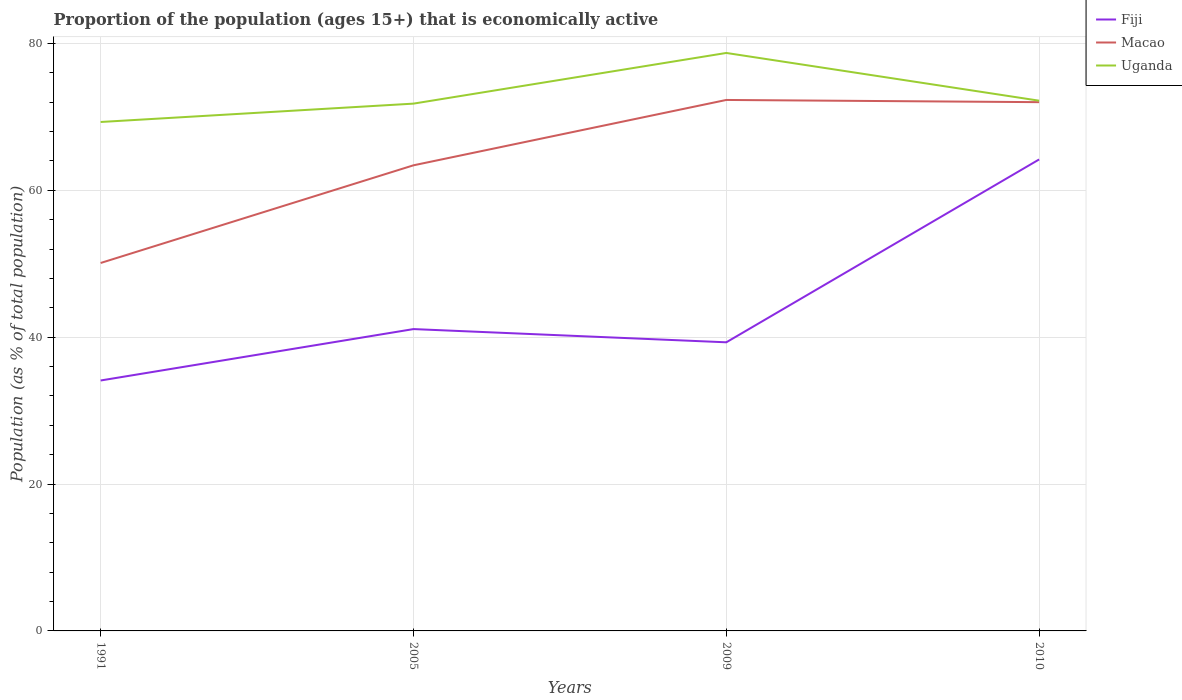How many different coloured lines are there?
Make the answer very short. 3. Is the number of lines equal to the number of legend labels?
Your response must be concise. Yes. Across all years, what is the maximum proportion of the population that is economically active in Uganda?
Ensure brevity in your answer.  69.3. What is the total proportion of the population that is economically active in Macao in the graph?
Offer a terse response. -13.3. What is the difference between the highest and the second highest proportion of the population that is economically active in Macao?
Make the answer very short. 22.2. Is the proportion of the population that is economically active in Uganda strictly greater than the proportion of the population that is economically active in Fiji over the years?
Offer a very short reply. No. How many lines are there?
Keep it short and to the point. 3. How many years are there in the graph?
Ensure brevity in your answer.  4. Does the graph contain any zero values?
Provide a succinct answer. No. Does the graph contain grids?
Offer a very short reply. Yes. Where does the legend appear in the graph?
Offer a very short reply. Top right. How are the legend labels stacked?
Offer a very short reply. Vertical. What is the title of the graph?
Your response must be concise. Proportion of the population (ages 15+) that is economically active. Does "San Marino" appear as one of the legend labels in the graph?
Your response must be concise. No. What is the label or title of the Y-axis?
Give a very brief answer. Population (as % of total population). What is the Population (as % of total population) in Fiji in 1991?
Provide a short and direct response. 34.1. What is the Population (as % of total population) of Macao in 1991?
Ensure brevity in your answer.  50.1. What is the Population (as % of total population) of Uganda in 1991?
Offer a terse response. 69.3. What is the Population (as % of total population) of Fiji in 2005?
Make the answer very short. 41.1. What is the Population (as % of total population) in Macao in 2005?
Offer a very short reply. 63.4. What is the Population (as % of total population) of Uganda in 2005?
Provide a succinct answer. 71.8. What is the Population (as % of total population) in Fiji in 2009?
Provide a short and direct response. 39.3. What is the Population (as % of total population) of Macao in 2009?
Provide a short and direct response. 72.3. What is the Population (as % of total population) of Uganda in 2009?
Your answer should be compact. 78.7. What is the Population (as % of total population) in Fiji in 2010?
Your answer should be very brief. 64.2. What is the Population (as % of total population) in Uganda in 2010?
Provide a succinct answer. 72.2. Across all years, what is the maximum Population (as % of total population) of Fiji?
Provide a short and direct response. 64.2. Across all years, what is the maximum Population (as % of total population) in Macao?
Provide a short and direct response. 72.3. Across all years, what is the maximum Population (as % of total population) in Uganda?
Make the answer very short. 78.7. Across all years, what is the minimum Population (as % of total population) in Fiji?
Give a very brief answer. 34.1. Across all years, what is the minimum Population (as % of total population) of Macao?
Your answer should be very brief. 50.1. Across all years, what is the minimum Population (as % of total population) of Uganda?
Give a very brief answer. 69.3. What is the total Population (as % of total population) in Fiji in the graph?
Ensure brevity in your answer.  178.7. What is the total Population (as % of total population) of Macao in the graph?
Keep it short and to the point. 257.8. What is the total Population (as % of total population) of Uganda in the graph?
Provide a succinct answer. 292. What is the difference between the Population (as % of total population) of Fiji in 1991 and that in 2005?
Your response must be concise. -7. What is the difference between the Population (as % of total population) in Macao in 1991 and that in 2005?
Provide a succinct answer. -13.3. What is the difference between the Population (as % of total population) of Uganda in 1991 and that in 2005?
Keep it short and to the point. -2.5. What is the difference between the Population (as % of total population) in Macao in 1991 and that in 2009?
Make the answer very short. -22.2. What is the difference between the Population (as % of total population) in Uganda in 1991 and that in 2009?
Offer a terse response. -9.4. What is the difference between the Population (as % of total population) in Fiji in 1991 and that in 2010?
Your response must be concise. -30.1. What is the difference between the Population (as % of total population) of Macao in 1991 and that in 2010?
Offer a terse response. -21.9. What is the difference between the Population (as % of total population) of Uganda in 2005 and that in 2009?
Ensure brevity in your answer.  -6.9. What is the difference between the Population (as % of total population) in Fiji in 2005 and that in 2010?
Make the answer very short. -23.1. What is the difference between the Population (as % of total population) in Macao in 2005 and that in 2010?
Offer a very short reply. -8.6. What is the difference between the Population (as % of total population) of Uganda in 2005 and that in 2010?
Give a very brief answer. -0.4. What is the difference between the Population (as % of total population) of Fiji in 2009 and that in 2010?
Make the answer very short. -24.9. What is the difference between the Population (as % of total population) of Fiji in 1991 and the Population (as % of total population) of Macao in 2005?
Your answer should be compact. -29.3. What is the difference between the Population (as % of total population) of Fiji in 1991 and the Population (as % of total population) of Uganda in 2005?
Make the answer very short. -37.7. What is the difference between the Population (as % of total population) in Macao in 1991 and the Population (as % of total population) in Uganda in 2005?
Your response must be concise. -21.7. What is the difference between the Population (as % of total population) of Fiji in 1991 and the Population (as % of total population) of Macao in 2009?
Offer a very short reply. -38.2. What is the difference between the Population (as % of total population) in Fiji in 1991 and the Population (as % of total population) in Uganda in 2009?
Your answer should be very brief. -44.6. What is the difference between the Population (as % of total population) in Macao in 1991 and the Population (as % of total population) in Uganda in 2009?
Make the answer very short. -28.6. What is the difference between the Population (as % of total population) of Fiji in 1991 and the Population (as % of total population) of Macao in 2010?
Keep it short and to the point. -37.9. What is the difference between the Population (as % of total population) in Fiji in 1991 and the Population (as % of total population) in Uganda in 2010?
Provide a short and direct response. -38.1. What is the difference between the Population (as % of total population) in Macao in 1991 and the Population (as % of total population) in Uganda in 2010?
Your answer should be compact. -22.1. What is the difference between the Population (as % of total population) in Fiji in 2005 and the Population (as % of total population) in Macao in 2009?
Your answer should be compact. -31.2. What is the difference between the Population (as % of total population) in Fiji in 2005 and the Population (as % of total population) in Uganda in 2009?
Keep it short and to the point. -37.6. What is the difference between the Population (as % of total population) in Macao in 2005 and the Population (as % of total population) in Uganda in 2009?
Offer a very short reply. -15.3. What is the difference between the Population (as % of total population) in Fiji in 2005 and the Population (as % of total population) in Macao in 2010?
Provide a succinct answer. -30.9. What is the difference between the Population (as % of total population) in Fiji in 2005 and the Population (as % of total population) in Uganda in 2010?
Provide a short and direct response. -31.1. What is the difference between the Population (as % of total population) of Macao in 2005 and the Population (as % of total population) of Uganda in 2010?
Your response must be concise. -8.8. What is the difference between the Population (as % of total population) in Fiji in 2009 and the Population (as % of total population) in Macao in 2010?
Your answer should be very brief. -32.7. What is the difference between the Population (as % of total population) in Fiji in 2009 and the Population (as % of total population) in Uganda in 2010?
Your response must be concise. -32.9. What is the average Population (as % of total population) of Fiji per year?
Ensure brevity in your answer.  44.67. What is the average Population (as % of total population) of Macao per year?
Offer a very short reply. 64.45. In the year 1991, what is the difference between the Population (as % of total population) in Fiji and Population (as % of total population) in Macao?
Offer a terse response. -16. In the year 1991, what is the difference between the Population (as % of total population) in Fiji and Population (as % of total population) in Uganda?
Ensure brevity in your answer.  -35.2. In the year 1991, what is the difference between the Population (as % of total population) of Macao and Population (as % of total population) of Uganda?
Your answer should be very brief. -19.2. In the year 2005, what is the difference between the Population (as % of total population) in Fiji and Population (as % of total population) in Macao?
Provide a succinct answer. -22.3. In the year 2005, what is the difference between the Population (as % of total population) in Fiji and Population (as % of total population) in Uganda?
Your response must be concise. -30.7. In the year 2009, what is the difference between the Population (as % of total population) in Fiji and Population (as % of total population) in Macao?
Make the answer very short. -33. In the year 2009, what is the difference between the Population (as % of total population) of Fiji and Population (as % of total population) of Uganda?
Your answer should be compact. -39.4. In the year 2009, what is the difference between the Population (as % of total population) of Macao and Population (as % of total population) of Uganda?
Offer a very short reply. -6.4. In the year 2010, what is the difference between the Population (as % of total population) of Fiji and Population (as % of total population) of Macao?
Provide a short and direct response. -7.8. In the year 2010, what is the difference between the Population (as % of total population) of Fiji and Population (as % of total population) of Uganda?
Provide a short and direct response. -8. In the year 2010, what is the difference between the Population (as % of total population) of Macao and Population (as % of total population) of Uganda?
Ensure brevity in your answer.  -0.2. What is the ratio of the Population (as % of total population) of Fiji in 1991 to that in 2005?
Give a very brief answer. 0.83. What is the ratio of the Population (as % of total population) in Macao in 1991 to that in 2005?
Make the answer very short. 0.79. What is the ratio of the Population (as % of total population) in Uganda in 1991 to that in 2005?
Provide a short and direct response. 0.97. What is the ratio of the Population (as % of total population) of Fiji in 1991 to that in 2009?
Your answer should be compact. 0.87. What is the ratio of the Population (as % of total population) in Macao in 1991 to that in 2009?
Offer a terse response. 0.69. What is the ratio of the Population (as % of total population) in Uganda in 1991 to that in 2009?
Your answer should be very brief. 0.88. What is the ratio of the Population (as % of total population) of Fiji in 1991 to that in 2010?
Your answer should be compact. 0.53. What is the ratio of the Population (as % of total population) in Macao in 1991 to that in 2010?
Offer a terse response. 0.7. What is the ratio of the Population (as % of total population) of Uganda in 1991 to that in 2010?
Your response must be concise. 0.96. What is the ratio of the Population (as % of total population) of Fiji in 2005 to that in 2009?
Give a very brief answer. 1.05. What is the ratio of the Population (as % of total population) of Macao in 2005 to that in 2009?
Offer a very short reply. 0.88. What is the ratio of the Population (as % of total population) in Uganda in 2005 to that in 2009?
Offer a very short reply. 0.91. What is the ratio of the Population (as % of total population) in Fiji in 2005 to that in 2010?
Your answer should be very brief. 0.64. What is the ratio of the Population (as % of total population) of Macao in 2005 to that in 2010?
Provide a short and direct response. 0.88. What is the ratio of the Population (as % of total population) of Fiji in 2009 to that in 2010?
Keep it short and to the point. 0.61. What is the ratio of the Population (as % of total population) in Uganda in 2009 to that in 2010?
Keep it short and to the point. 1.09. What is the difference between the highest and the second highest Population (as % of total population) of Fiji?
Provide a succinct answer. 23.1. What is the difference between the highest and the lowest Population (as % of total population) of Fiji?
Your answer should be compact. 30.1. 